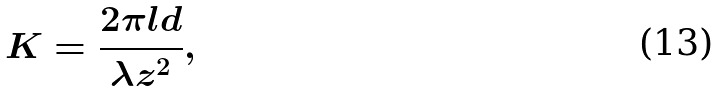<formula> <loc_0><loc_0><loc_500><loc_500>K = \frac { 2 \pi l d } { \lambda z ^ { 2 } } ,</formula> 